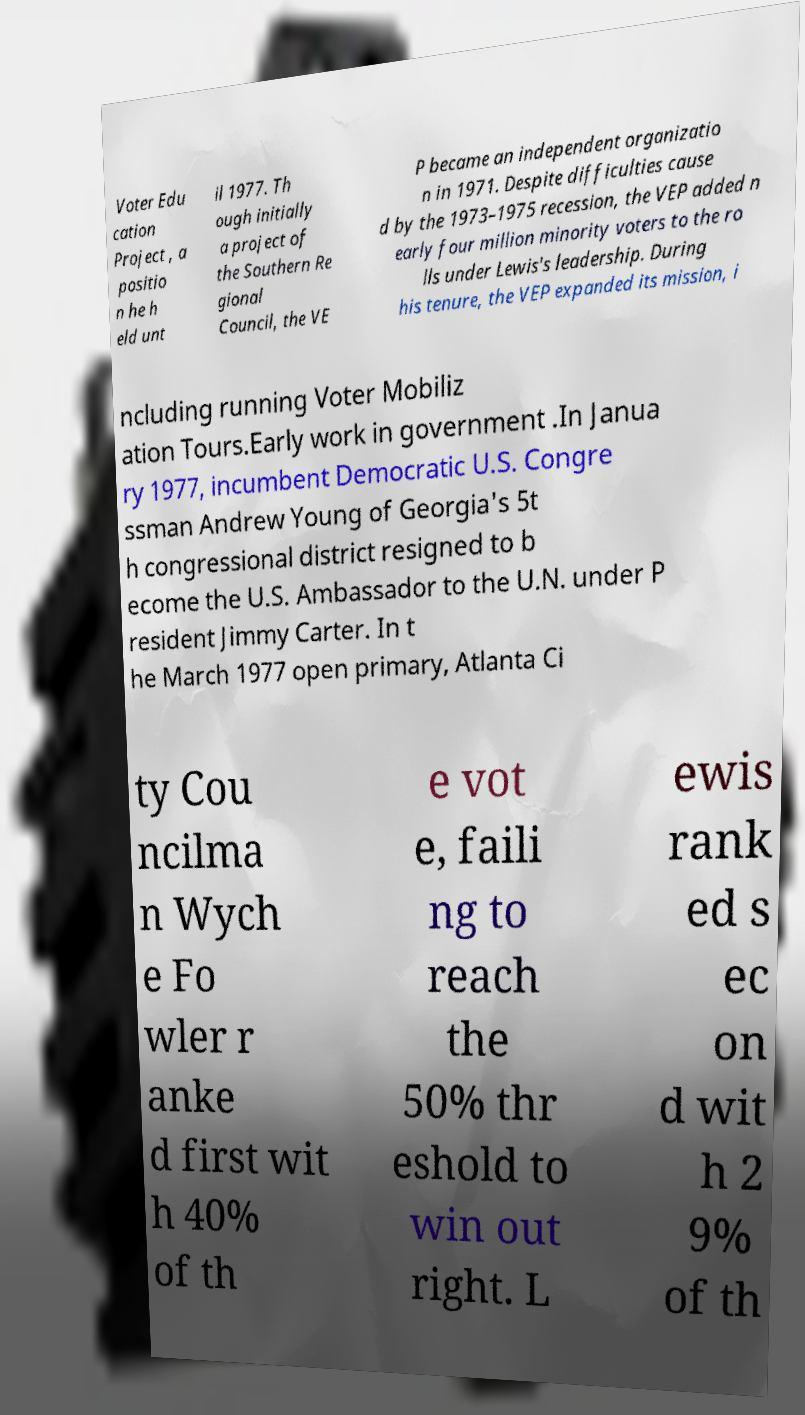Please identify and transcribe the text found in this image. Voter Edu cation Project , a positio n he h eld unt il 1977. Th ough initially a project of the Southern Re gional Council, the VE P became an independent organizatio n in 1971. Despite difficulties cause d by the 1973–1975 recession, the VEP added n early four million minority voters to the ro lls under Lewis's leadership. During his tenure, the VEP expanded its mission, i ncluding running Voter Mobiliz ation Tours.Early work in government .In Janua ry 1977, incumbent Democratic U.S. Congre ssman Andrew Young of Georgia's 5t h congressional district resigned to b ecome the U.S. Ambassador to the U.N. under P resident Jimmy Carter. In t he March 1977 open primary, Atlanta Ci ty Cou ncilma n Wych e Fo wler r anke d first wit h 40% of th e vot e, faili ng to reach the 50% thr eshold to win out right. L ewis rank ed s ec on d wit h 2 9% of th 